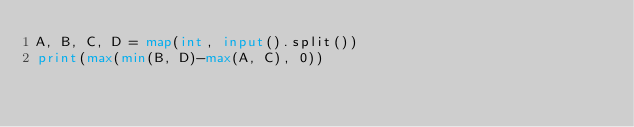<code> <loc_0><loc_0><loc_500><loc_500><_Python_>A, B, C, D = map(int, input().split())
print(max(min(B, D)-max(A, C), 0))</code> 